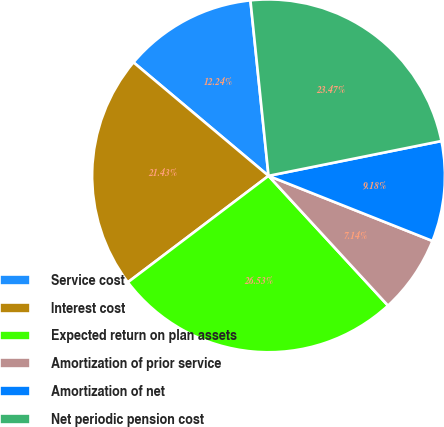Convert chart. <chart><loc_0><loc_0><loc_500><loc_500><pie_chart><fcel>Service cost<fcel>Interest cost<fcel>Expected return on plan assets<fcel>Amortization of prior service<fcel>Amortization of net<fcel>Net periodic pension cost<nl><fcel>12.24%<fcel>21.43%<fcel>26.53%<fcel>7.14%<fcel>9.18%<fcel>23.47%<nl></chart> 